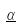Convert formula to latex. <formula><loc_0><loc_0><loc_500><loc_500>\underline { \alpha }</formula> 